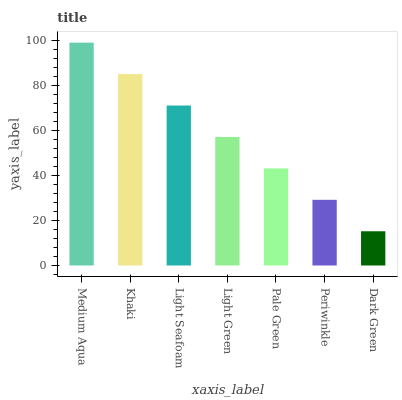Is Khaki the minimum?
Answer yes or no. No. Is Khaki the maximum?
Answer yes or no. No. Is Medium Aqua greater than Khaki?
Answer yes or no. Yes. Is Khaki less than Medium Aqua?
Answer yes or no. Yes. Is Khaki greater than Medium Aqua?
Answer yes or no. No. Is Medium Aqua less than Khaki?
Answer yes or no. No. Is Light Green the high median?
Answer yes or no. Yes. Is Light Green the low median?
Answer yes or no. Yes. Is Dark Green the high median?
Answer yes or no. No. Is Medium Aqua the low median?
Answer yes or no. No. 